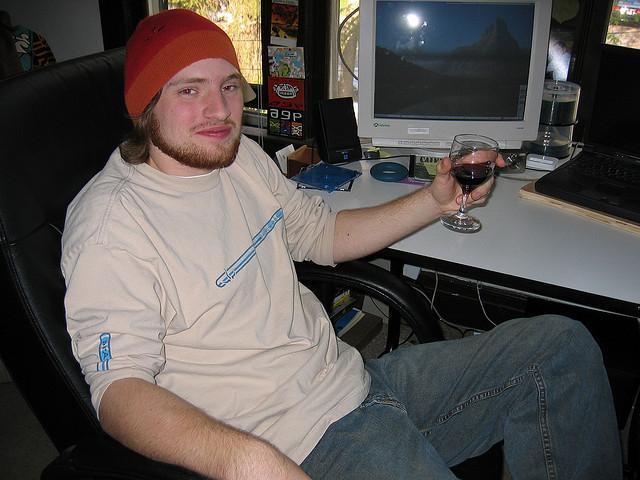How many people are wearing blue jeans in this photo?
Give a very brief answer. 1. How many caps in the picture?
Give a very brief answer. 1. How many clocks are visible in this photo?
Give a very brief answer. 0. 